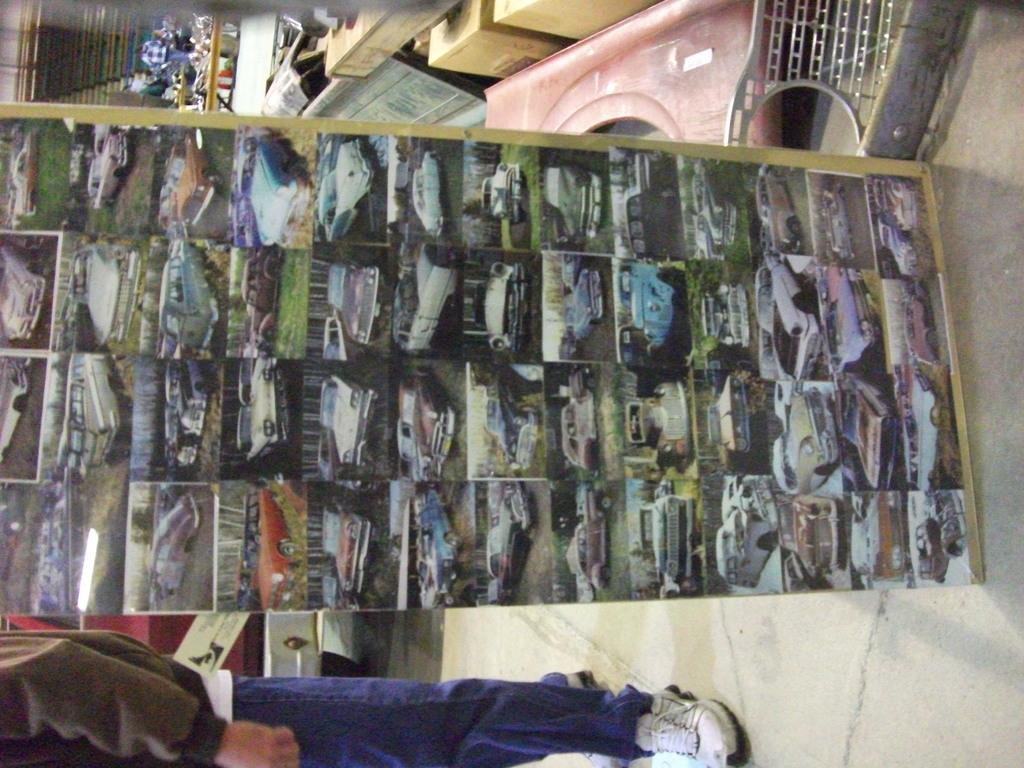What is displayed on the board in the image? There are pictures of vehicles on a board in the image. Can you describe the person in the image? There is a person standing in the image. What can be seen in the background of the image? There are multi-colored objects in the background of the image. What type of clover is growing in the basin in the image? There is no clover or basin present in the image. What is the person eating for breakfast in the image? There is no breakfast or indication of food consumption in the image. 